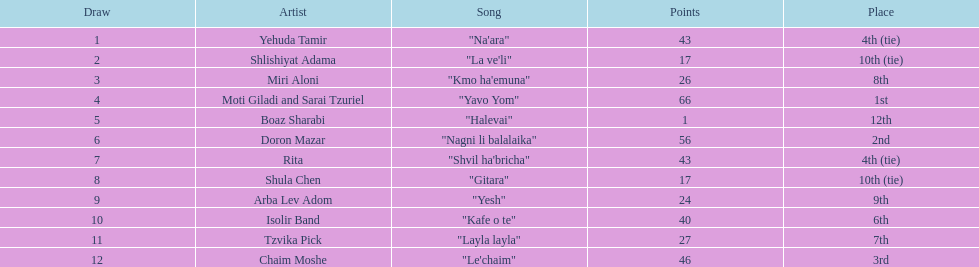What is the count of first place achievements by an artist? 1. 